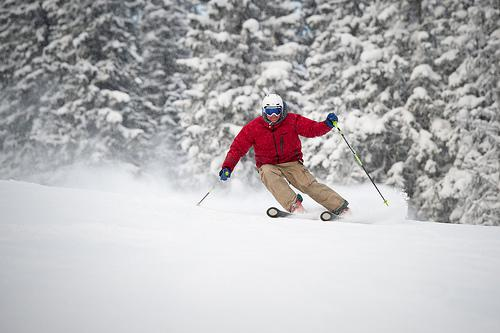Question: how many animals?
Choices:
A. Two.
B. Four.
C. None.
D. Five.
Answer with the letter. Answer: C Question: who is in the picture?
Choices:
A. Chef.
B. Skier.
C. Baseball player.
D. Child.
Answer with the letter. Answer: B Question: where is the skier?
Choices:
A. In ski boots.
B. Gazebo.
C. In snow.
D. In cabin.
Answer with the letter. Answer: C 